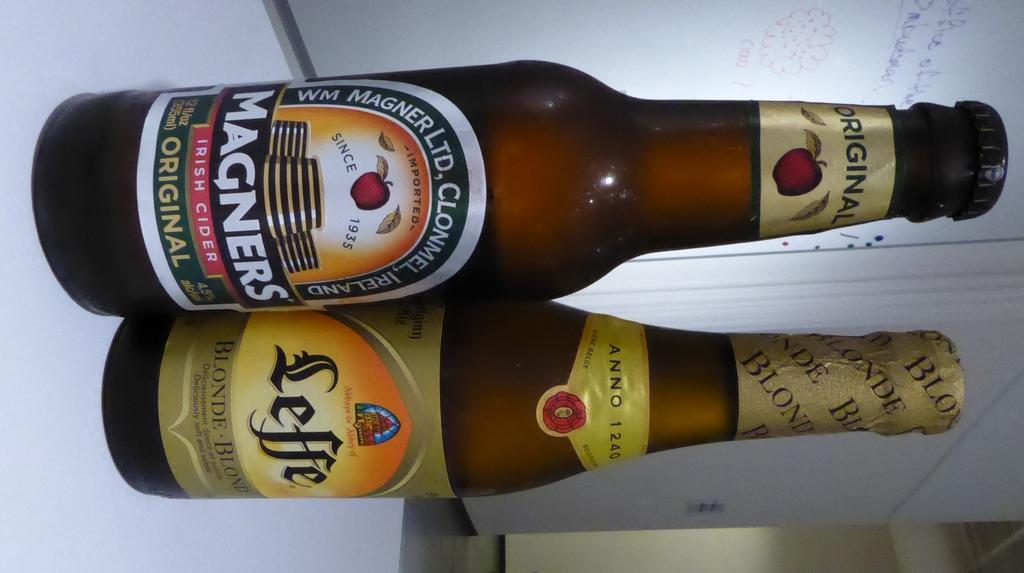<image>
Describe the image concisely. One bottle of Magners Cider and one bottle of Leffe Blonde set on a white table. 